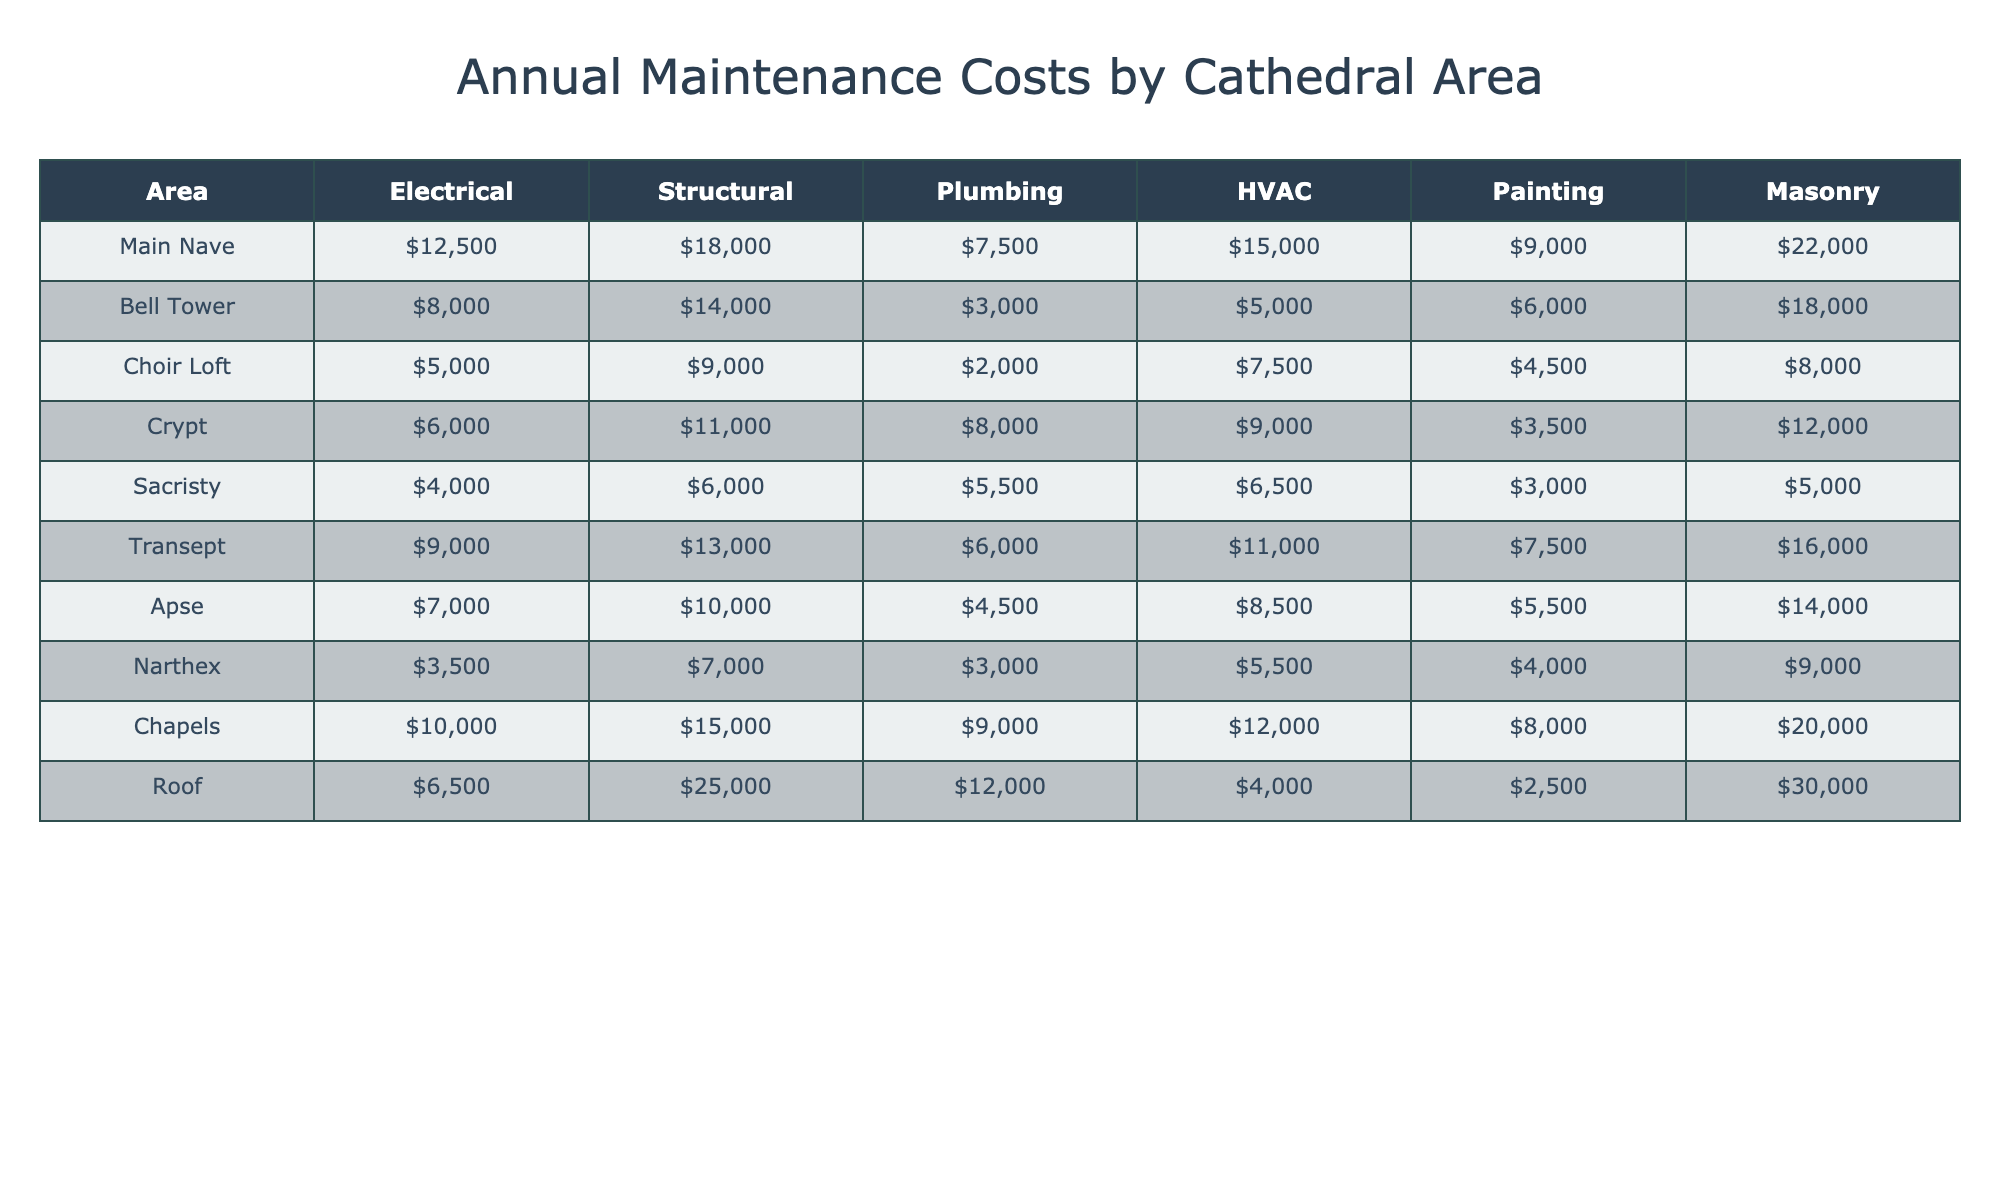What is the total annual maintenance cost for the Main Nave? The Main Nave has maintenance costs of 12,500 for Electrical, 18,000 for Structural, 7,500 for Plumbing, 15,000 for HVAC, 9,000 for Painting, and 22,000 for Masonry. To find the total, we sum these values: 12,500 + 18,000 + 7,500 + 15,000 + 9,000 + 22,000 = 84,000.
Answer: 84,000 Which area has the lowest annual plumbing costs? The plumbing costs for each area are: Main Nave (7,500), Bell Tower (3,000), Choir Loft (2,000), Crypt (8,000), Sacristy (5,500), Transept (6,000), Apse (4,500), Narthex (3,000), Chapels (9,000), and Roof (12,000). The lowest cost is for the Choir Loft at 2,000.
Answer: Choir Loft What is the average HVAC cost across all areas? The HVAC costs are: Main Nave (15,000), Bell Tower (5,000), Choir Loft (7,500), Crypt (9,000), Sacristy (6,500), Transept (11,000), Apse (8,500), Narthex (5,500), Chapels (12,000), and Roof (4,000). There are 10 areas, so the average is (15,000 + 5,000 + 7,500 + 9,000 + 6,500 + 11,000 + 8,500 + 5,500 + 12,000 + 4,000) / 10 = 7,500.
Answer: 7,500 Is the total painting cost for the Chapels greater than the total plumbing cost for the Crypt? The painting cost for the Chapels is 8,000, and the plumbing cost for the Crypt is 8,000 as well. Therefore, it is neither greater nor less, making the statement false.
Answer: False Which area experiences the highest total maintenance cost and what is that amount? To find this, we must calculate the total maintenance costs for each area: Main Nave (84,000), Bell Tower (38,000), Choir Loft (27,000), Crypt (30,500), Sacristy (18,000), Transept (50,500), Apse (36,000), Narthex (18,000), Chapels (84,000), and Roof (70,500). The highest is tied between Main Nave and Chapels, both at 84,000.
Answer: Main Nave and Chapels, 84,000 What is the difference in masonry maintenance costs between the Bell Tower and the Roof? The masonry cost for the Bell Tower is 18,000, and for the Roof, it is 30,000. To find the difference, subtract the Bell Tower’s cost from the Roof’s: 30,000 - 18,000 = 12,000.
Answer: 12,000 Which area has a higher total maintenance cost, the Choir Loft or the Crypt? The total maintenance cost for the Choir Loft is 27,000 and for the Crypt is 30,500. Since 30,500 is greater than 27,000, the Crypt has the higher cost.
Answer: Crypt Is the structural maintenance cost for the Sacristy equal to the plumbing cost for the Narthex? The structural maintenance cost for the Sacristy is 6,000, and the plumbing cost for the Narthex is 3,000. Since 6,000 is not equal to 3,000, the statement is false.
Answer: False What is the total maintenance cost for all areas combined? The total costs for each area sum up to: Main Nave (84,000), Bell Tower (38,000), Choir Loft (27,000), Crypt (30,500), Sacristy (18,000), Transept (50,500), Apse (36,000), Narthex (18,000), Chapels (84,000), and Roof (70,500). Therefore, the total is 84,000 + 38,000 + 27,000 + 30,500 + 18,000 + 50,500 + 36,000 + 18,000 + 84,000 + 70,500 = 437,500.
Answer: 437,500 